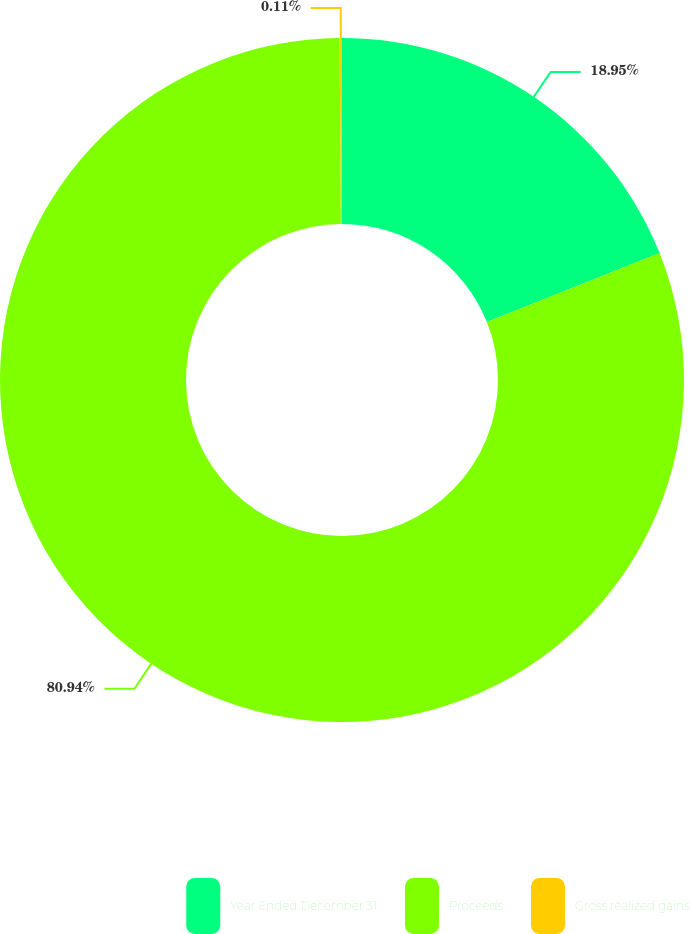Convert chart. <chart><loc_0><loc_0><loc_500><loc_500><pie_chart><fcel>Year Ended December 31<fcel>Proceeds<fcel>Gross realized gains<nl><fcel>18.95%<fcel>80.94%<fcel>0.11%<nl></chart> 